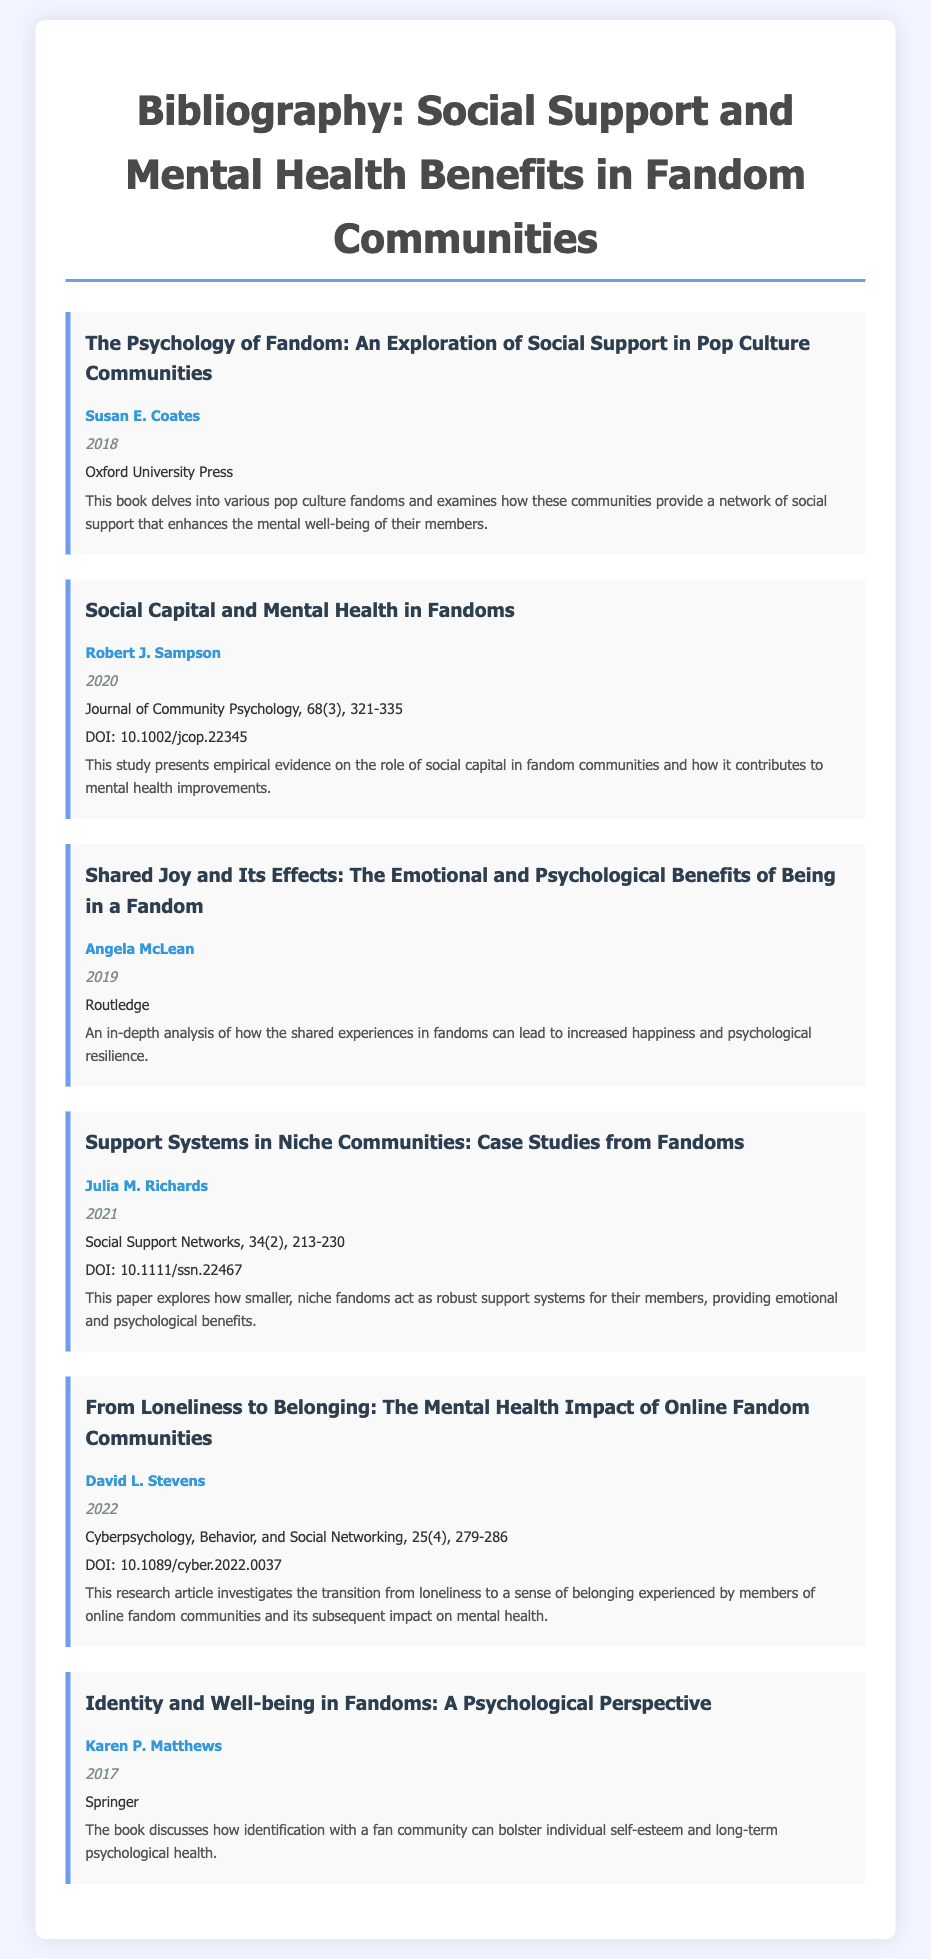what is the title of the first entry? The title of the first entry is the name of the work by Susan E. Coates.
Answer: The Psychology of Fandom: An Exploration of Social Support in Pop Culture Communities who is the author of the entry published in 2020? The author of the entry published in 2020 is listed directly under the title.
Answer: Robert J. Sampson what year was the paper by Julia M. Richards published? The year of publication for Julia M. Richards' paper is indicated in it.
Answer: 2021 how many pages does "Shared Joy and Its Effects" have in the bibliography? The bibliographic entry does not specify the page count; it is a general description.
Answer: Not specified what is the DOI for the article by David L. Stevens? The DOI is provided in the bibliographic entry for the article, indicating a unique identifier for it.
Answer: 10.1089/cyber.2022.0037 what aspect of fandom communities does the book by Karen P. Matthews focus on? The focus is indicated in the description of the book regarding psychological aspects.
Answer: Identity and Well-being which publisher released the book by Angela McLean? The publisher is listed directly beneath the author's name in the entry.
Answer: Routledge what genre does the work by Susan E. Coates belong to? The genre is indicated in the context of fandom and social support communities described in the entry.
Answer: Book 